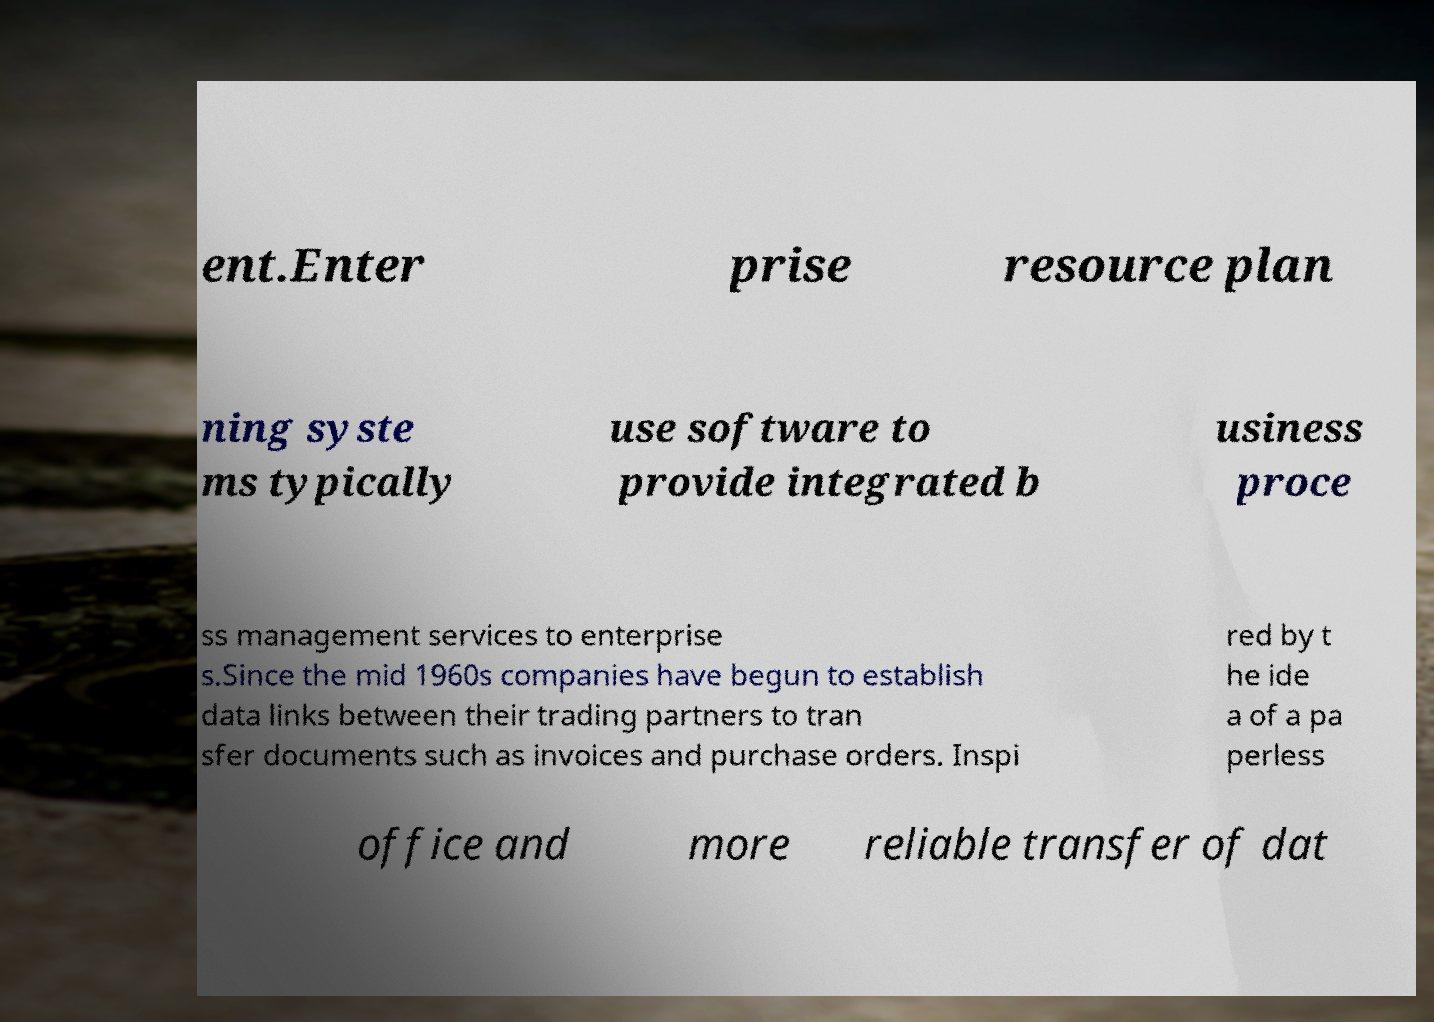Can you accurately transcribe the text from the provided image for me? ent.Enter prise resource plan ning syste ms typically use software to provide integrated b usiness proce ss management services to enterprise s.Since the mid 1960s companies have begun to establish data links between their trading partners to tran sfer documents such as invoices and purchase orders. Inspi red by t he ide a of a pa perless office and more reliable transfer of dat 